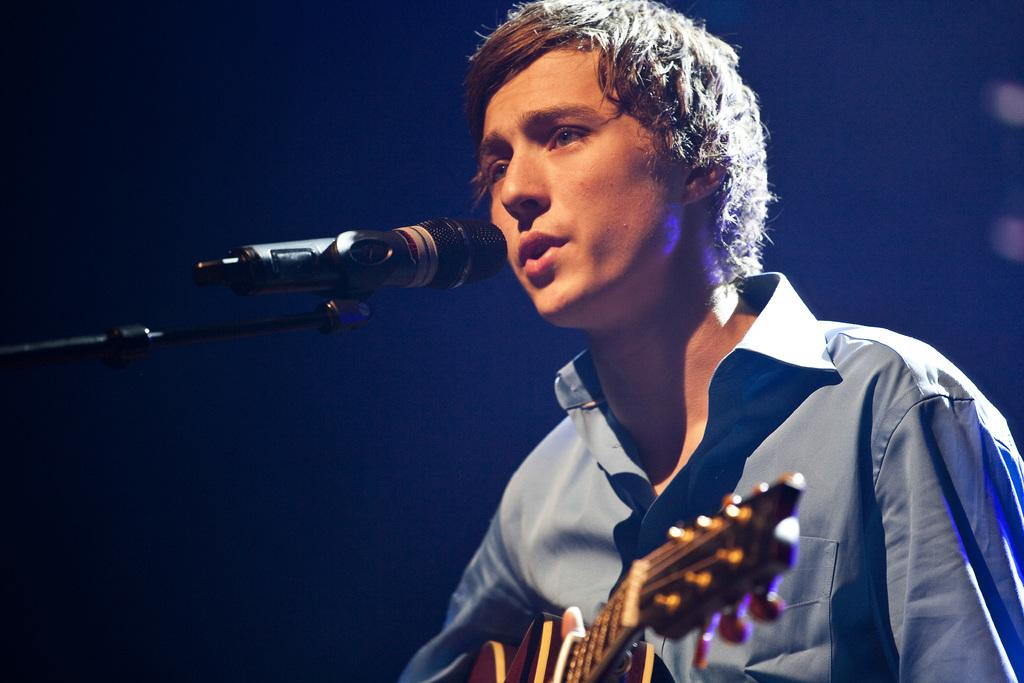What is the main subject of the image? The main subject of the image is a man. What is the man holding in the image? The man is holding a musical instrument. Can you describe the setup around the man? There is a microphone placed in front of the man. What type of protest can be seen happening in the image? There is no protest visible in the image; it features a man holding a musical instrument with a microphone in front of him. What kind of ray is emitting from the musical instrument in the image? There is no ray emitting from the musical instrument in the image. 